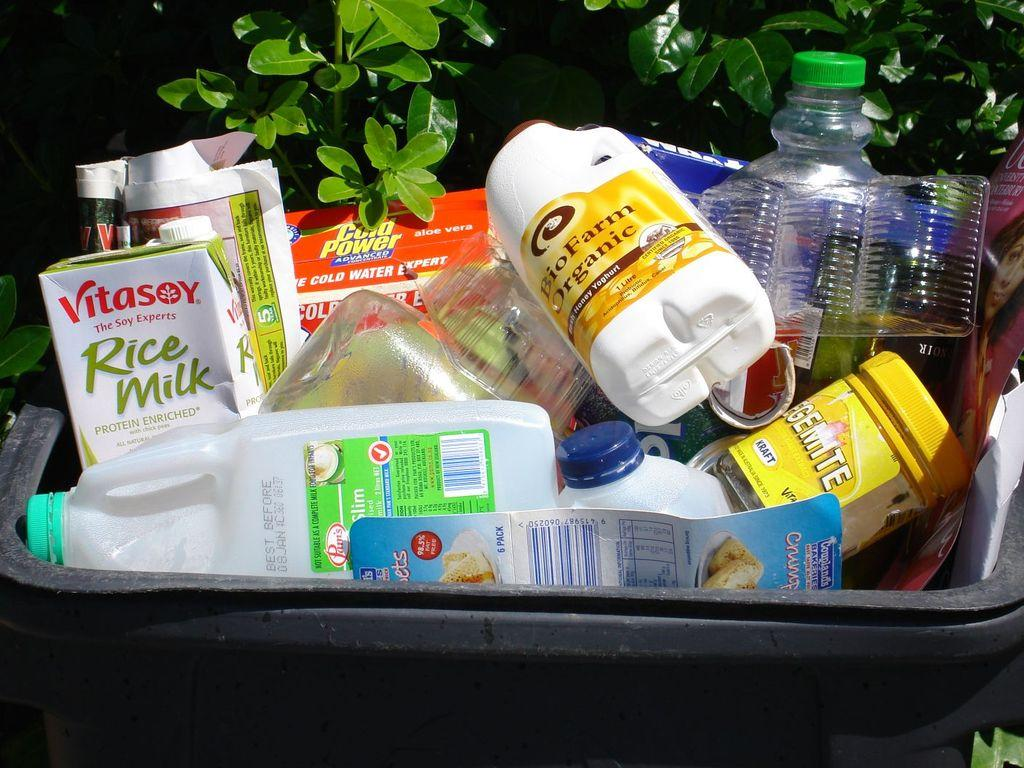What type of containers are visible in the image? There are plastic boxes in the image. What color is the tub containing the plastic boxes? The tub is black in color. Where is the tub located in the image? The tub is in the center of the image. What type of vegetation can be seen in the image? There are leaves at the bottom and top of the image. Is there a cat using the umbrella to provide shade for the plastic boxes in the image? There is no cat or umbrella present in the image, so this scenario cannot be observed. 